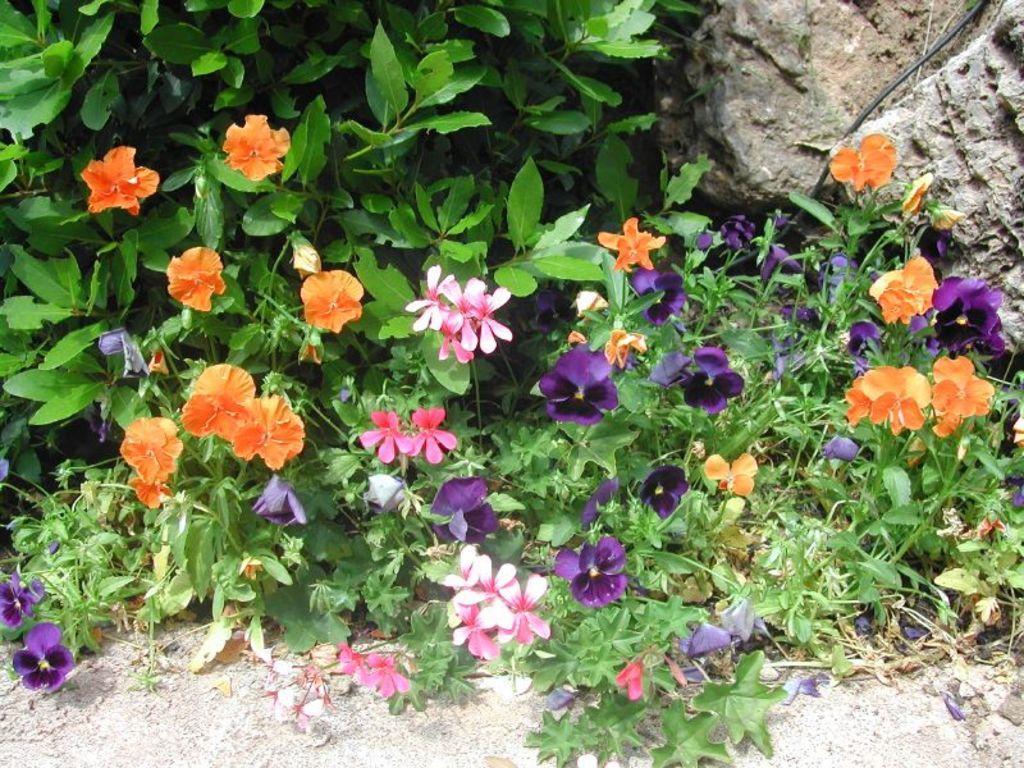In one or two sentences, can you explain what this image depicts? This image is taken outdoors. At the bottom of the image there is a ground. In the middle of the image there are a few plants with green leaves, stems and different colors of flowers. At the top right of the image there is a rock. 